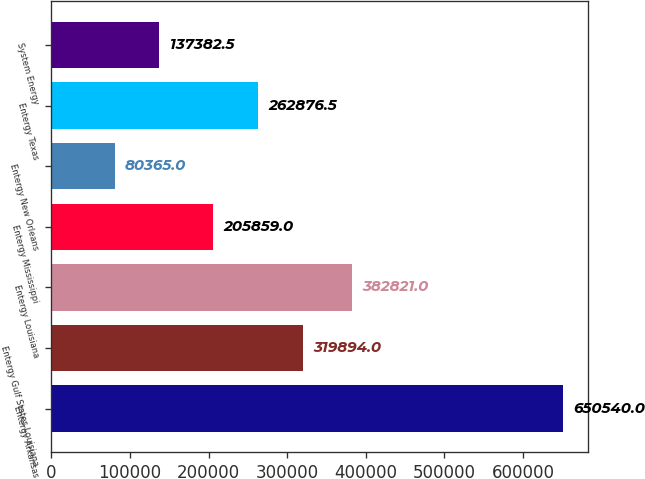Convert chart to OTSL. <chart><loc_0><loc_0><loc_500><loc_500><bar_chart><fcel>Entergy Arkansas<fcel>Entergy Gulf States Louisiana<fcel>Entergy Louisiana<fcel>Entergy Mississippi<fcel>Entergy New Orleans<fcel>Entergy Texas<fcel>System Energy<nl><fcel>650540<fcel>319894<fcel>382821<fcel>205859<fcel>80365<fcel>262876<fcel>137382<nl></chart> 